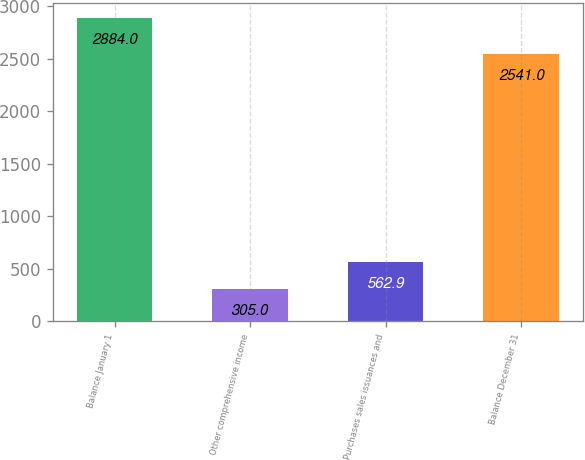Convert chart to OTSL. <chart><loc_0><loc_0><loc_500><loc_500><bar_chart><fcel>Balance January 1<fcel>Other comprehensive income<fcel>Purchases sales issuances and<fcel>Balance December 31<nl><fcel>2884<fcel>305<fcel>562.9<fcel>2541<nl></chart> 